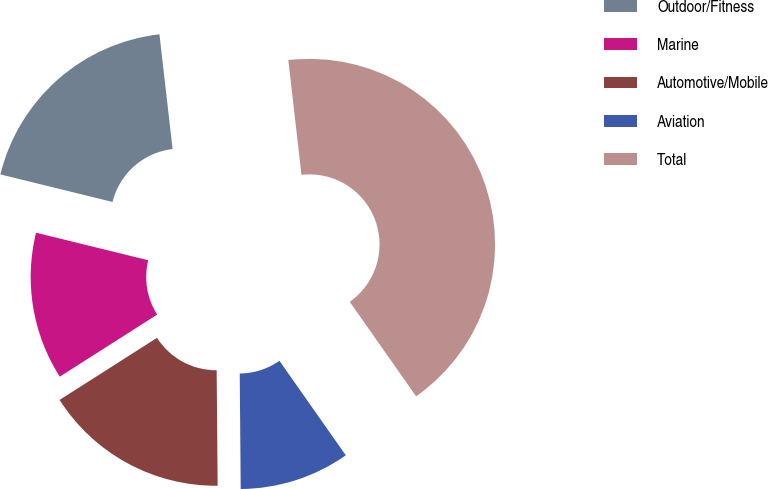Convert chart to OTSL. <chart><loc_0><loc_0><loc_500><loc_500><pie_chart><fcel>Outdoor/Fitness<fcel>Marine<fcel>Automotive/Mobile<fcel>Aviation<fcel>Total<nl><fcel>19.35%<fcel>12.86%<fcel>16.1%<fcel>9.61%<fcel>42.07%<nl></chart> 